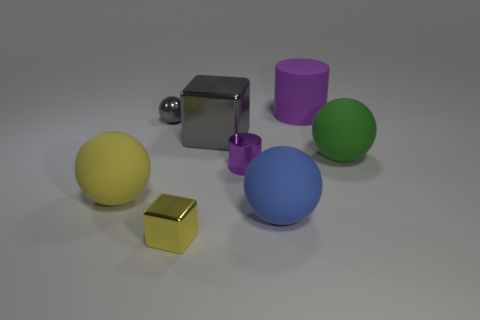Subtract all large blue balls. How many balls are left? 3 Subtract all yellow blocks. How many blocks are left? 1 Add 1 cubes. How many objects exist? 9 Subtract 2 spheres. How many spheres are left? 2 Subtract 0 blue cylinders. How many objects are left? 8 Subtract all blocks. How many objects are left? 6 Subtract all brown spheres. Subtract all red cylinders. How many spheres are left? 4 Subtract all gray blocks. How many cyan spheres are left? 0 Subtract all big yellow spheres. Subtract all big green spheres. How many objects are left? 6 Add 8 blue matte objects. How many blue matte objects are left? 9 